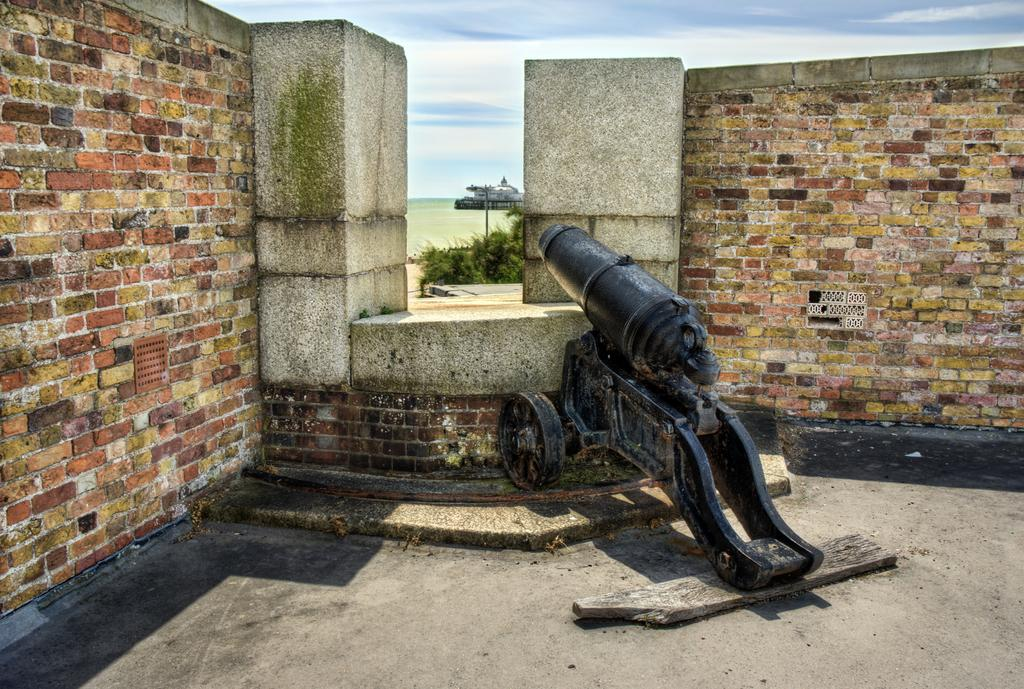What is the main object in the image? There is a cannon in the image. What color is the cannon? The cannon is black in color. What can be seen in the background of the image? There is a wall in the background of the image. What colors are the wall? The wall is white and brown in color. What structure is visible in the image? There is a building visible in the image. What colors are the sky in the image? The sky is blue and white in color. What type of plough can be seen at the edge of the image? There is no plough present in the image. What color is the edge of the cannon in the image? The edge of the cannon is not mentioned in the provided facts, but the cannon itself is black in color. 